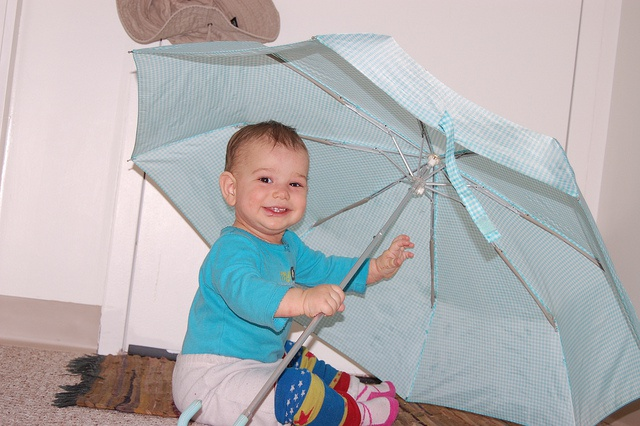Describe the objects in this image and their specific colors. I can see umbrella in lightgray, darkgray, and lightblue tones and people in lightgray, lightpink, lightblue, darkgray, and teal tones in this image. 